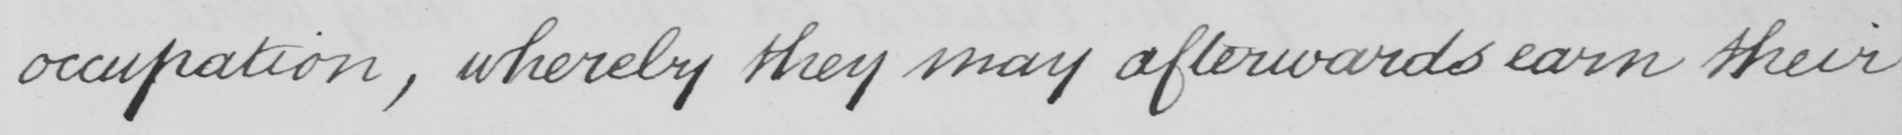Transcribe the text shown in this historical manuscript line. occupation , whereby they may afterwards earn their 